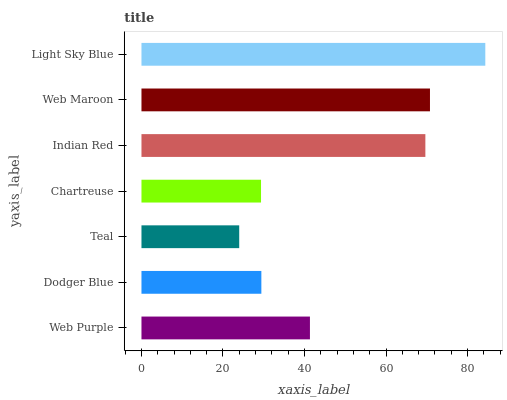Is Teal the minimum?
Answer yes or no. Yes. Is Light Sky Blue the maximum?
Answer yes or no. Yes. Is Dodger Blue the minimum?
Answer yes or no. No. Is Dodger Blue the maximum?
Answer yes or no. No. Is Web Purple greater than Dodger Blue?
Answer yes or no. Yes. Is Dodger Blue less than Web Purple?
Answer yes or no. Yes. Is Dodger Blue greater than Web Purple?
Answer yes or no. No. Is Web Purple less than Dodger Blue?
Answer yes or no. No. Is Web Purple the high median?
Answer yes or no. Yes. Is Web Purple the low median?
Answer yes or no. Yes. Is Web Maroon the high median?
Answer yes or no. No. Is Dodger Blue the low median?
Answer yes or no. No. 